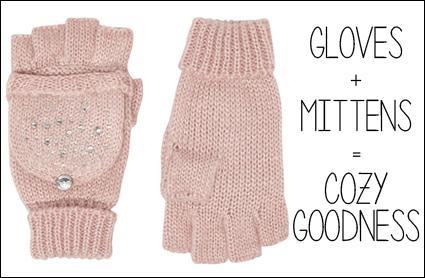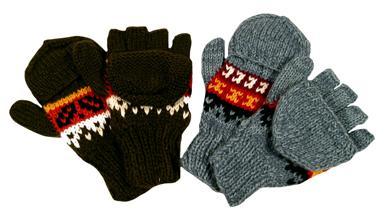The first image is the image on the left, the second image is the image on the right. Evaluate the accuracy of this statement regarding the images: "The gloves are made of a knitted material.". Is it true? Answer yes or no. Yes. 